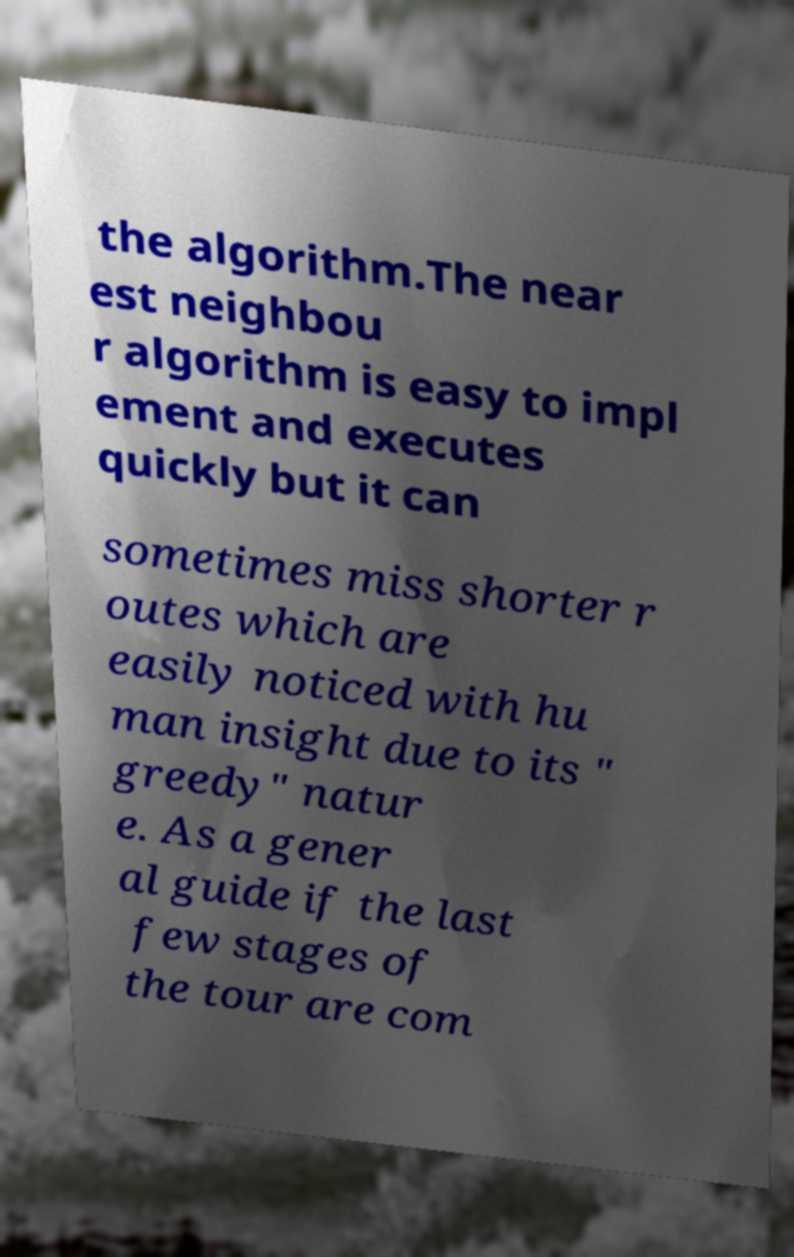Can you read and provide the text displayed in the image?This photo seems to have some interesting text. Can you extract and type it out for me? the algorithm.The near est neighbou r algorithm is easy to impl ement and executes quickly but it can sometimes miss shorter r outes which are easily noticed with hu man insight due to its " greedy" natur e. As a gener al guide if the last few stages of the tour are com 